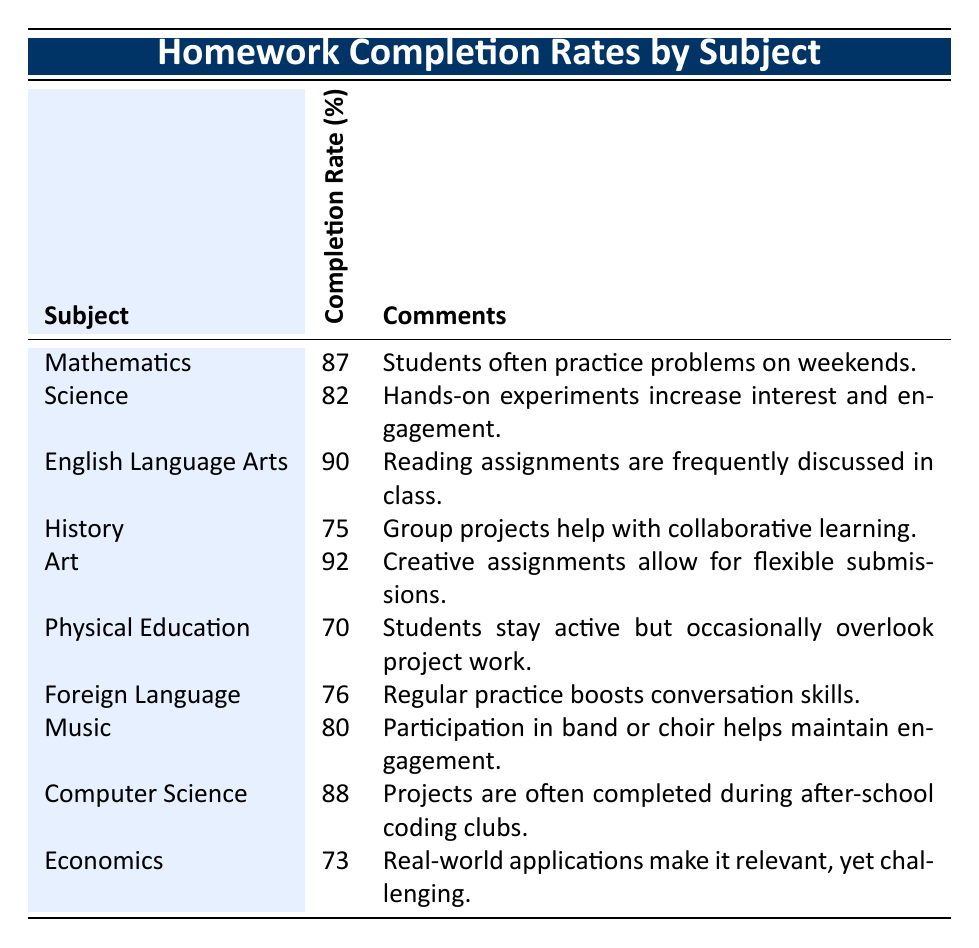What is the completion rate for English Language Arts? The table shows that the completion rate for English Language Arts is listed directly under the Completion Rate column. It states 90%.
Answer: 90% Which subject has the highest completion rate? By comparing the completion rates in the Completion Rate column, we see that Art has the highest completion rate at 92%.
Answer: 92% What is the difference in completion rates between Mathematics and Science? Mathematics has a completion rate of 87% and Science has a completion rate of 82%. The difference is calculated as 87 - 82 = 5.
Answer: 5 Is the completion rate for Physical Education above 75%? The table indicates that the completion rate for Physical Education is 70%, which is below 75%. Therefore, the answer is no.
Answer: No What is the average completion rate for the following subjects: History, Foreign Language, and Economics? The completion rates for these subjects are 75%, 76%, and 73%, respectively. To find the average, we sum these rates: 75 + 76 + 73 = 224. There are 3 subjects, so the average is 224 / 3 = approximately 74.67.
Answer: 74.67 Which subjects have completion rates below 80%? By reviewing the table, Physical Education (70%), History (75%), and Economics (73%) all have completion rates below 80%.
Answer: Physical Education, History, Economics What is the median completion rate of all subjects listed in the table? To find the median, we first list the completion rates in order: 70, 73, 75, 76, 80, 82, 87, 88, 90, 92. There are 10 values, so the median is the average of the 5th and 6th values (80 and 82). Thus, the median is (80 + 82) / 2 = 81.
Answer: 81 Do students tend to have a higher completion rate in subjects with hands-on activities? From the table, Science (82%) has hands-on experiments, and it is one of the subjects with a higher completion rate. Other hands-on subjects like Art (92%) also have high completion rates. Thus, the answer is yes since both subjects reflect higher rates.
Answer: Yes How many subjects have completion rates above 80%? By examining the table, the subjects with completion rates above 80% are Art (92%), English Language Arts (90%), Computer Science (88%), and Mathematics (87%). There are 4 subjects in total.
Answer: 4 